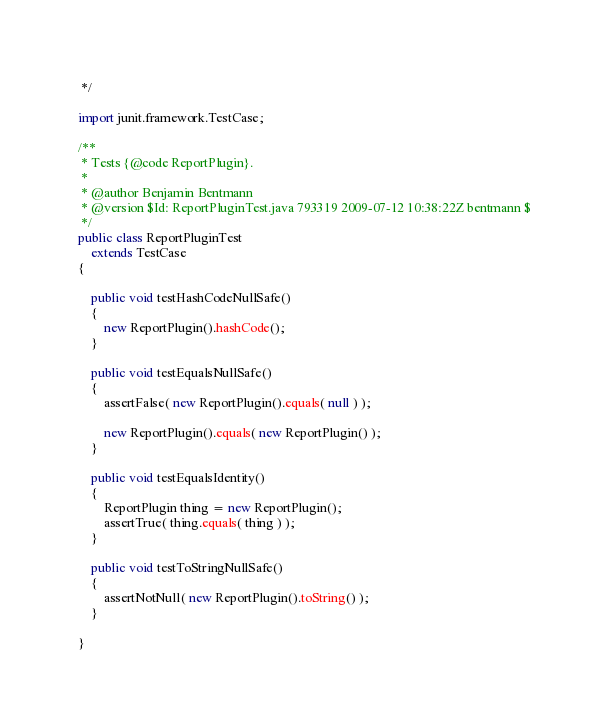<code> <loc_0><loc_0><loc_500><loc_500><_Java_> */

import junit.framework.TestCase;

/**
 * Tests {@code ReportPlugin}.
 * 
 * @author Benjamin Bentmann
 * @version $Id: ReportPluginTest.java 793319 2009-07-12 10:38:22Z bentmann $
 */
public class ReportPluginTest
    extends TestCase
{

    public void testHashCodeNullSafe()
    {
        new ReportPlugin().hashCode();
    }

    public void testEqualsNullSafe()
    {
        assertFalse( new ReportPlugin().equals( null ) );

        new ReportPlugin().equals( new ReportPlugin() );
    }

    public void testEqualsIdentity()
    {
        ReportPlugin thing = new ReportPlugin();
        assertTrue( thing.equals( thing ) );
    }

    public void testToStringNullSafe()
    {
        assertNotNull( new ReportPlugin().toString() );
    }

}
</code> 